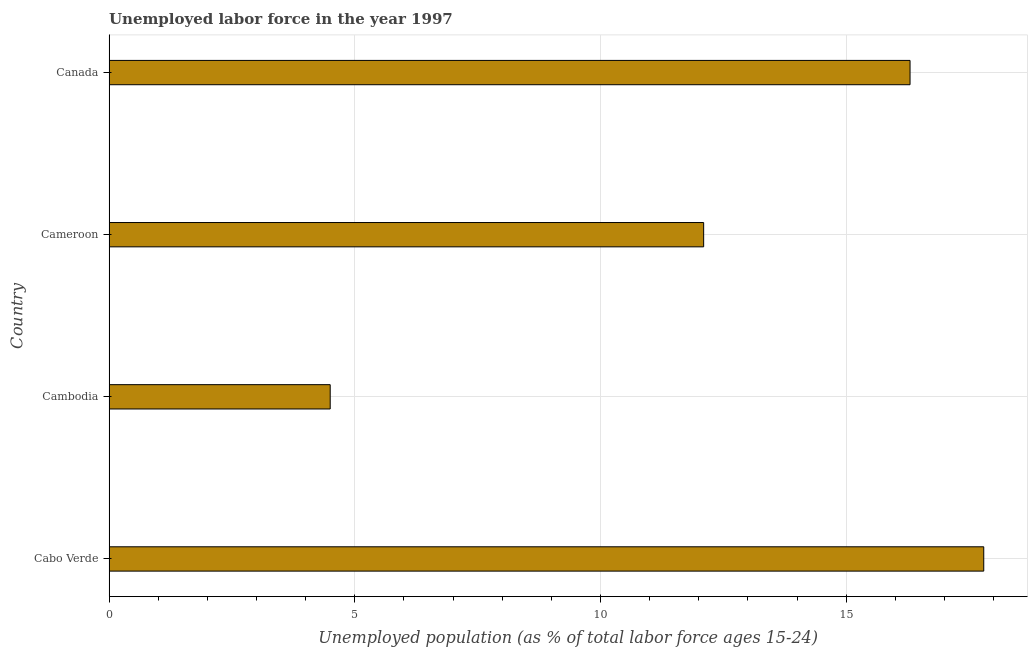Does the graph contain grids?
Ensure brevity in your answer.  Yes. What is the title of the graph?
Offer a very short reply. Unemployed labor force in the year 1997. What is the label or title of the X-axis?
Your answer should be very brief. Unemployed population (as % of total labor force ages 15-24). What is the total unemployed youth population in Cabo Verde?
Provide a short and direct response. 17.8. Across all countries, what is the maximum total unemployed youth population?
Provide a short and direct response. 17.8. In which country was the total unemployed youth population maximum?
Offer a very short reply. Cabo Verde. In which country was the total unemployed youth population minimum?
Ensure brevity in your answer.  Cambodia. What is the sum of the total unemployed youth population?
Provide a short and direct response. 50.7. What is the difference between the total unemployed youth population in Cabo Verde and Cameroon?
Give a very brief answer. 5.7. What is the average total unemployed youth population per country?
Ensure brevity in your answer.  12.68. What is the median total unemployed youth population?
Give a very brief answer. 14.2. In how many countries, is the total unemployed youth population greater than 11 %?
Provide a short and direct response. 3. What is the ratio of the total unemployed youth population in Cabo Verde to that in Canada?
Give a very brief answer. 1.09. Is the difference between the total unemployed youth population in Cambodia and Cameroon greater than the difference between any two countries?
Give a very brief answer. No. In how many countries, is the total unemployed youth population greater than the average total unemployed youth population taken over all countries?
Offer a very short reply. 2. How many countries are there in the graph?
Offer a very short reply. 4. What is the Unemployed population (as % of total labor force ages 15-24) of Cabo Verde?
Give a very brief answer. 17.8. What is the Unemployed population (as % of total labor force ages 15-24) in Cameroon?
Provide a succinct answer. 12.1. What is the Unemployed population (as % of total labor force ages 15-24) in Canada?
Your answer should be very brief. 16.3. What is the difference between the Unemployed population (as % of total labor force ages 15-24) in Cabo Verde and Canada?
Provide a succinct answer. 1.5. What is the difference between the Unemployed population (as % of total labor force ages 15-24) in Cambodia and Canada?
Offer a very short reply. -11.8. What is the difference between the Unemployed population (as % of total labor force ages 15-24) in Cameroon and Canada?
Your answer should be very brief. -4.2. What is the ratio of the Unemployed population (as % of total labor force ages 15-24) in Cabo Verde to that in Cambodia?
Ensure brevity in your answer.  3.96. What is the ratio of the Unemployed population (as % of total labor force ages 15-24) in Cabo Verde to that in Cameroon?
Give a very brief answer. 1.47. What is the ratio of the Unemployed population (as % of total labor force ages 15-24) in Cabo Verde to that in Canada?
Your response must be concise. 1.09. What is the ratio of the Unemployed population (as % of total labor force ages 15-24) in Cambodia to that in Cameroon?
Offer a very short reply. 0.37. What is the ratio of the Unemployed population (as % of total labor force ages 15-24) in Cambodia to that in Canada?
Keep it short and to the point. 0.28. What is the ratio of the Unemployed population (as % of total labor force ages 15-24) in Cameroon to that in Canada?
Make the answer very short. 0.74. 